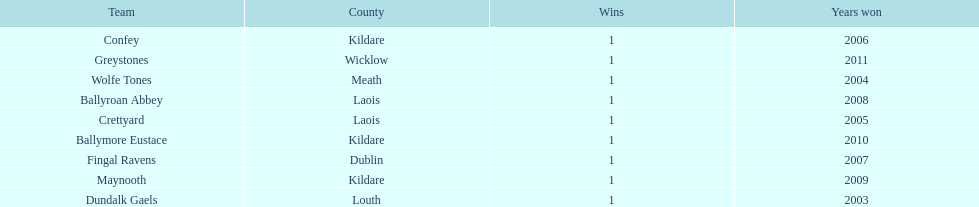How many wins did confey have? 1. 